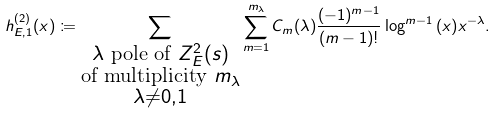<formula> <loc_0><loc_0><loc_500><loc_500>h _ { E , 1 } ^ { ( 2 ) } ( x ) \coloneqq \sum _ { \substack { \text {$\lambda$ pole of $Z_{E}^{2}(s)$} \\ \text {of multiplicity $m_{\lambda}$} \\ \lambda \neq 0 , 1 } } \sum _ { m = 1 } ^ { m _ { \lambda } } C _ { m } ( \lambda ) \frac { ( - 1 ) ^ { m - 1 } } { ( m - 1 ) ! } \log ^ { m - 1 } { ( x ) } x ^ { - \lambda } .</formula> 